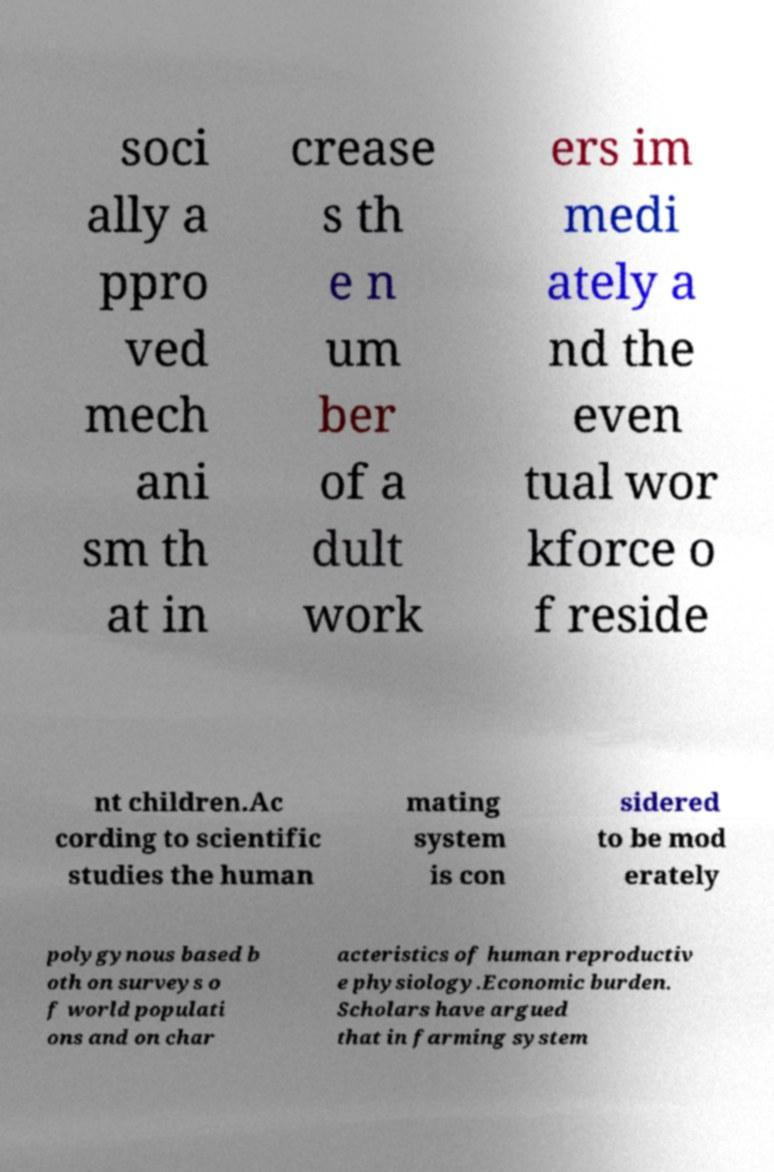I need the written content from this picture converted into text. Can you do that? soci ally a ppro ved mech ani sm th at in crease s th e n um ber of a dult work ers im medi ately a nd the even tual wor kforce o f reside nt children.Ac cording to scientific studies the human mating system is con sidered to be mod erately polygynous based b oth on surveys o f world populati ons and on char acteristics of human reproductiv e physiology.Economic burden. Scholars have argued that in farming system 